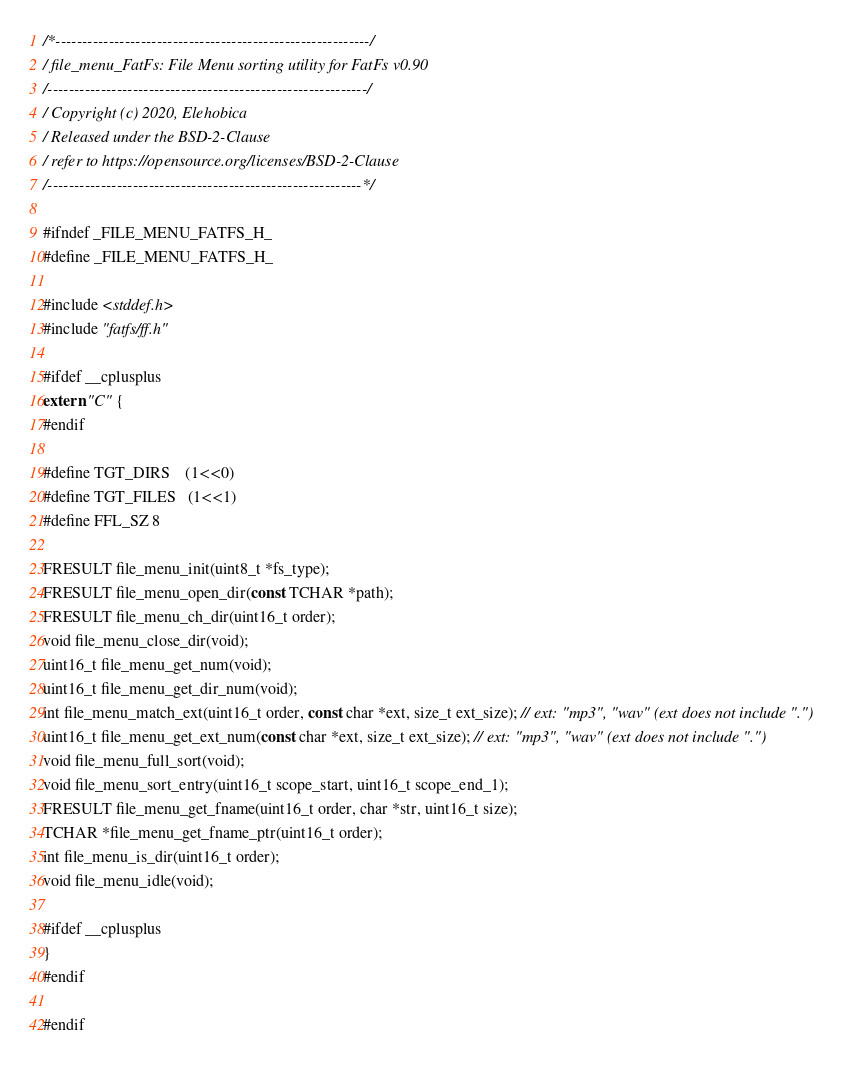Convert code to text. <code><loc_0><loc_0><loc_500><loc_500><_C_>/*-----------------------------------------------------------/
/ file_menu_FatFs: File Menu sorting utility for FatFs v0.90
/------------------------------------------------------------/
/ Copyright (c) 2020, Elehobica
/ Released under the BSD-2-Clause
/ refer to https://opensource.org/licenses/BSD-2-Clause
/-----------------------------------------------------------*/

#ifndef _FILE_MENU_FATFS_H_
#define _FILE_MENU_FATFS_H_

#include <stddef.h>
#include "fatfs/ff.h"

#ifdef __cplusplus
extern "C" {
#endif

#define TGT_DIRS    (1<<0)
#define TGT_FILES   (1<<1)
#define FFL_SZ 8

FRESULT file_menu_init(uint8_t *fs_type);
FRESULT file_menu_open_dir(const TCHAR *path);
FRESULT file_menu_ch_dir(uint16_t order);
void file_menu_close_dir(void);
uint16_t file_menu_get_num(void);
uint16_t file_menu_get_dir_num(void);
int file_menu_match_ext(uint16_t order, const char *ext, size_t ext_size); // ext: "mp3", "wav" (ext does not include ".")
uint16_t file_menu_get_ext_num(const char *ext, size_t ext_size); // ext: "mp3", "wav" (ext does not include ".")
void file_menu_full_sort(void);
void file_menu_sort_entry(uint16_t scope_start, uint16_t scope_end_1);
FRESULT file_menu_get_fname(uint16_t order, char *str, uint16_t size);
TCHAR *file_menu_get_fname_ptr(uint16_t order);
int file_menu_is_dir(uint16_t order);
void file_menu_idle(void);

#ifdef __cplusplus
}
#endif

#endif
</code> 